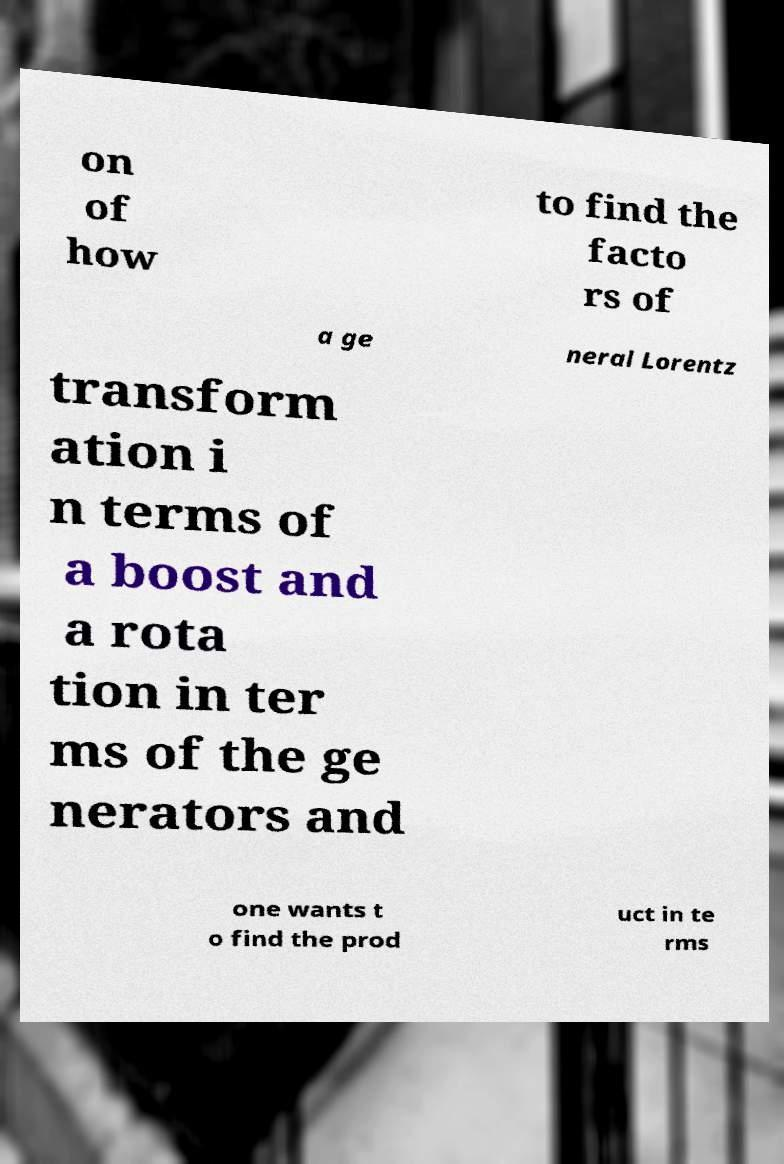I need the written content from this picture converted into text. Can you do that? on of how to find the facto rs of a ge neral Lorentz transform ation i n terms of a boost and a rota tion in ter ms of the ge nerators and one wants t o find the prod uct in te rms 